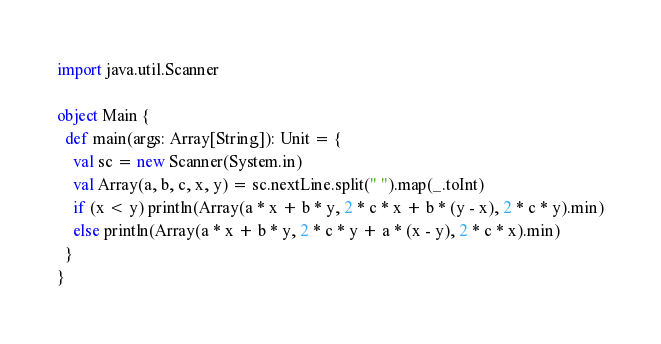Convert code to text. <code><loc_0><loc_0><loc_500><loc_500><_Scala_>import java.util.Scanner

object Main {
  def main(args: Array[String]): Unit = {
    val sc = new Scanner(System.in)
    val Array(a, b, c, x, y) = sc.nextLine.split(" ").map(_.toInt)
    if (x < y) println(Array(a * x + b * y, 2 * c * x + b * (y - x), 2 * c * y).min)
    else println(Array(a * x + b * y, 2 * c * y + a * (x - y), 2 * c * x).min)
  }
}
</code> 